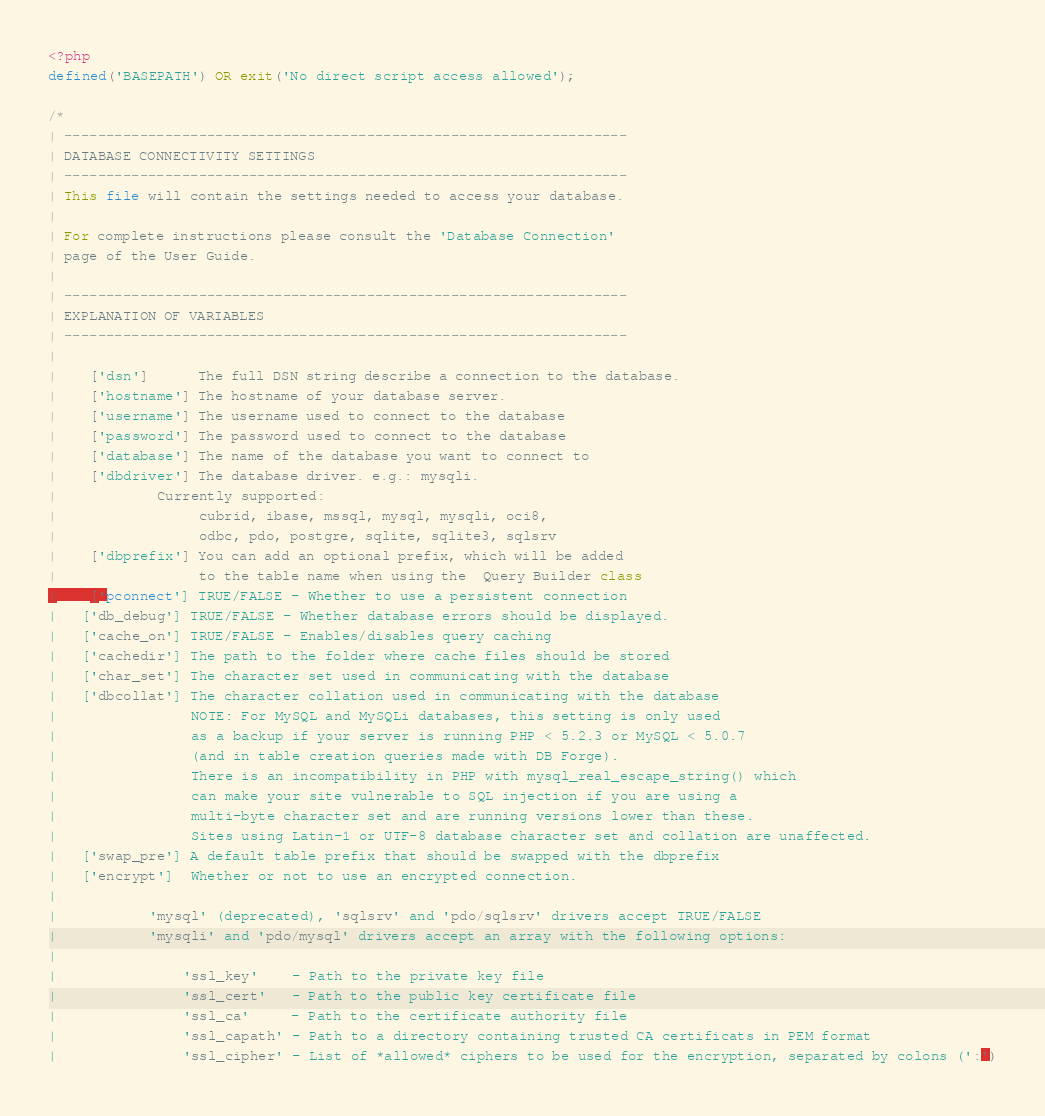Convert code to text. <code><loc_0><loc_0><loc_500><loc_500><_PHP_><?php
defined('BASEPATH') OR exit('No direct script access allowed');

/*
| -------------------------------------------------------------------
| DATABASE CONNECTIVITY SETTINGS
| -------------------------------------------------------------------
| This file will contain the settings needed to access your database.
|
| For complete instructions please consult the 'Database Connection'
| page of the User Guide.
|
| -------------------------------------------------------------------
| EXPLANATION OF VARIABLES
| -------------------------------------------------------------------
|
|	['dsn']      The full DSN string describe a connection to the database.
|	['hostname'] The hostname of your database server.
|	['username'] The username used to connect to the database
|	['password'] The password used to connect to the database
|	['database'] The name of the database you want to connect to
|	['dbdriver'] The database driver. e.g.: mysqli.
|			Currently supported:
|				 cubrid, ibase, mssql, mysql, mysqli, oci8,
|				 odbc, pdo, postgre, sqlite, sqlite3, sqlsrv
|	['dbprefix'] You can add an optional prefix, which will be added
|				 to the table name when using the  Query Builder class
|	['pconnect'] TRUE/FALSE - Whether to use a persistent connection
|	['db_debug'] TRUE/FALSE - Whether database errors should be displayed.
|	['cache_on'] TRUE/FALSE - Enables/disables query caching
|	['cachedir'] The path to the folder where cache files should be stored
|	['char_set'] The character set used in communicating with the database
|	['dbcollat'] The character collation used in communicating with the database
|				 NOTE: For MySQL and MySQLi databases, this setting is only used
| 				 as a backup if your server is running PHP < 5.2.3 or MySQL < 5.0.7
|				 (and in table creation queries made with DB Forge).
| 				 There is an incompatibility in PHP with mysql_real_escape_string() which
| 				 can make your site vulnerable to SQL injection if you are using a
| 				 multi-byte character set and are running versions lower than these.
| 				 Sites using Latin-1 or UTF-8 database character set and collation are unaffected.
|	['swap_pre'] A default table prefix that should be swapped with the dbprefix
|	['encrypt']  Whether or not to use an encrypted connection.
|
|			'mysql' (deprecated), 'sqlsrv' and 'pdo/sqlsrv' drivers accept TRUE/FALSE
|			'mysqli' and 'pdo/mysql' drivers accept an array with the following options:
|
|				'ssl_key'    - Path to the private key file
|				'ssl_cert'   - Path to the public key certificate file
|				'ssl_ca'     - Path to the certificate authority file
|				'ssl_capath' - Path to a directory containing trusted CA certificats in PEM format
|				'ssl_cipher' - List of *allowed* ciphers to be used for the encryption, separated by colons (':')</code> 